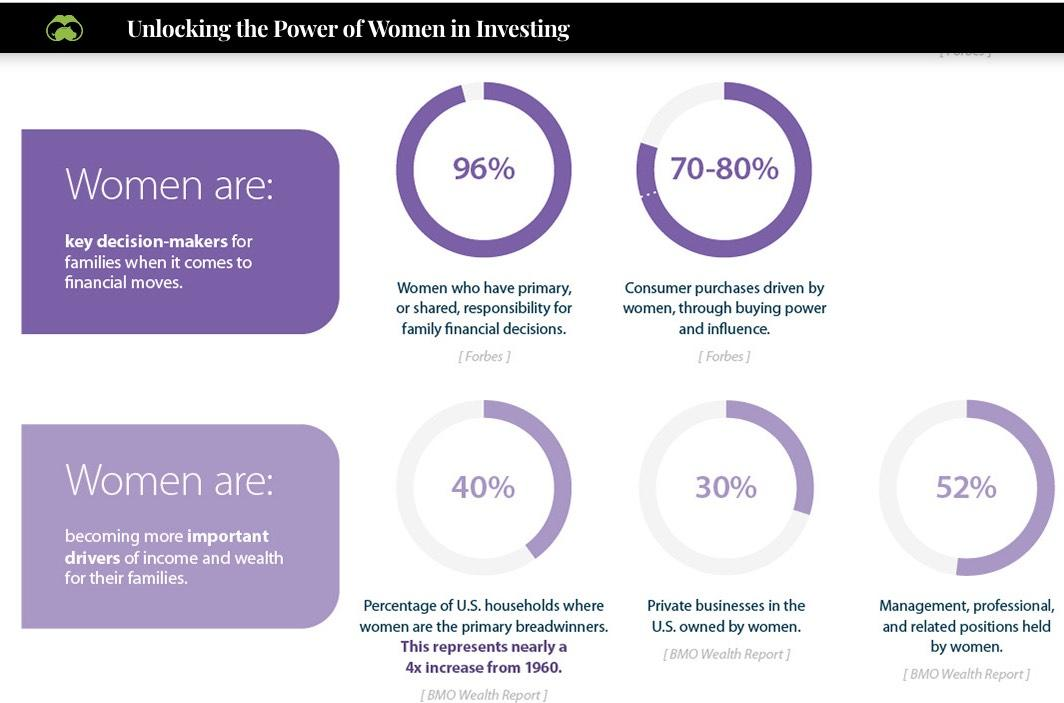Specify some key components in this picture. According to reliable sources, women play a significant role in driving consumer purchases, with buying power and influence estimated to account for 70-80% of total purchases. According to recent statistics, approximately 30% of private businesses in the United States are owned by women. Approximately 52% of management, professional, and related positions are held by women. 